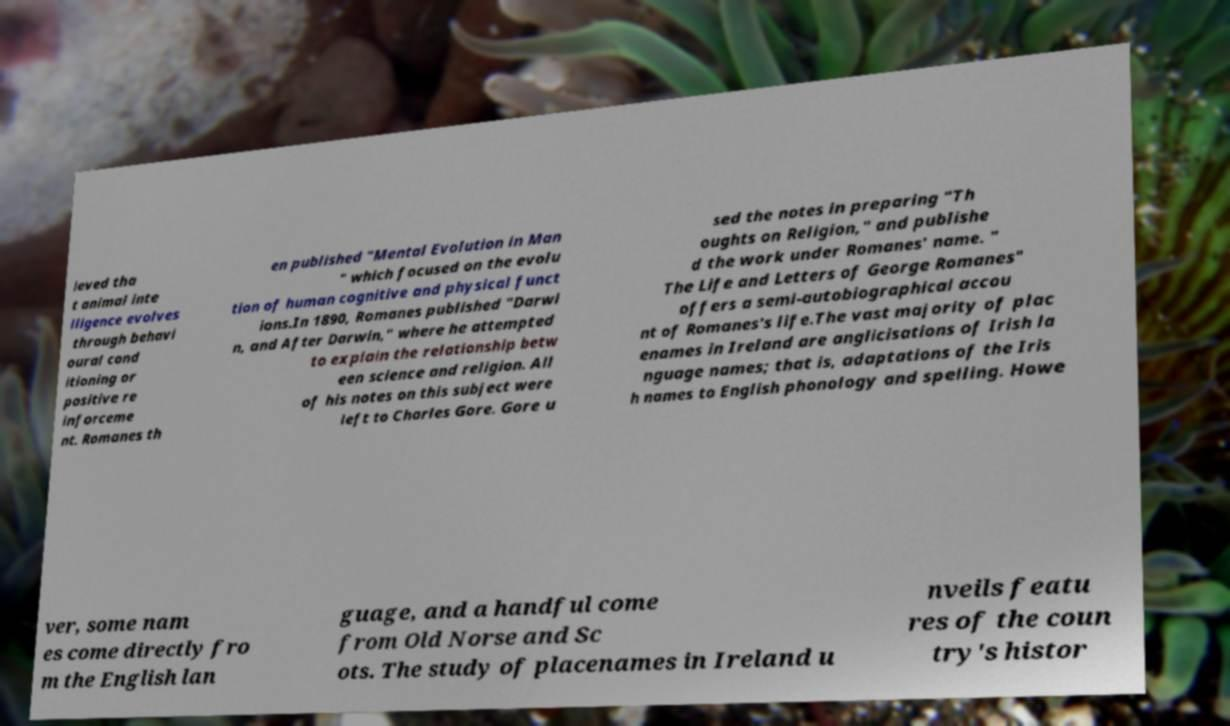Could you assist in decoding the text presented in this image and type it out clearly? ieved tha t animal inte lligence evolves through behavi oural cond itioning or positive re inforceme nt. Romanes th en published "Mental Evolution in Man " which focused on the evolu tion of human cognitive and physical funct ions.In 1890, Romanes published "Darwi n, and After Darwin," where he attempted to explain the relationship betw een science and religion. All of his notes on this subject were left to Charles Gore. Gore u sed the notes in preparing "Th oughts on Religion," and publishe d the work under Romanes' name. " The Life and Letters of George Romanes" offers a semi-autobiographical accou nt of Romanes's life.The vast majority of plac enames in Ireland are anglicisations of Irish la nguage names; that is, adaptations of the Iris h names to English phonology and spelling. Howe ver, some nam es come directly fro m the English lan guage, and a handful come from Old Norse and Sc ots. The study of placenames in Ireland u nveils featu res of the coun try's histor 